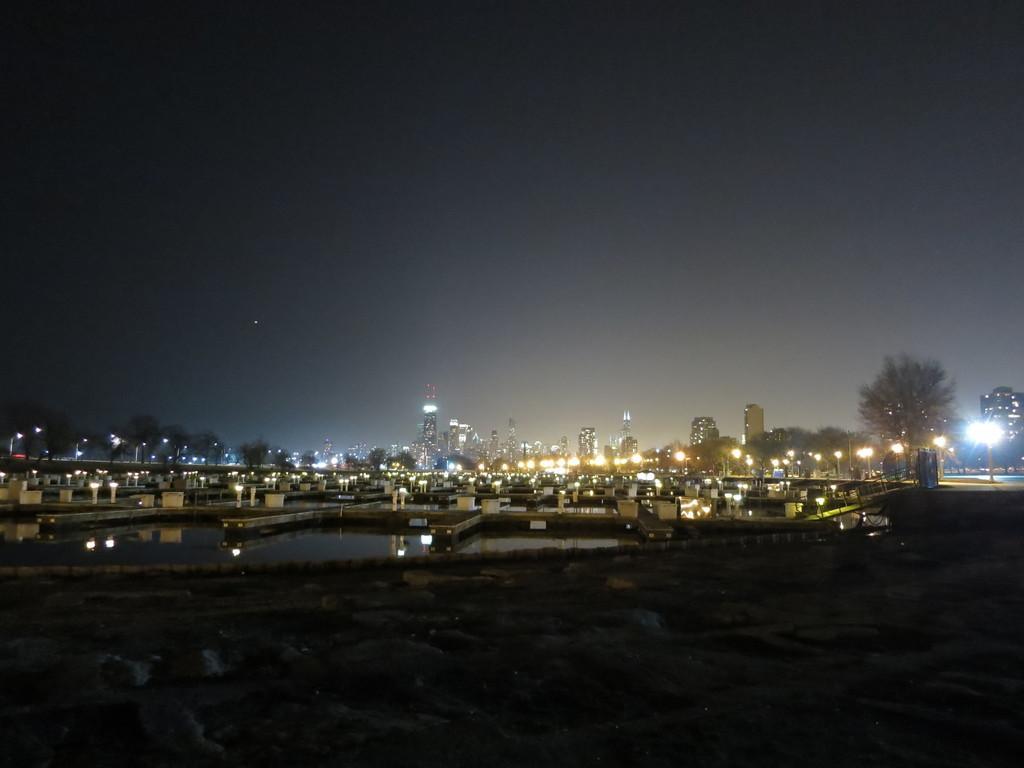Describe this image in one or two sentences. In this image there is water in the middle of the image. In the water there is some construction. In the background there are so many buildings with the lights. On the right side there are trees. At the bottom there is land. At the top there is the sky. This image is taken during the night time. 